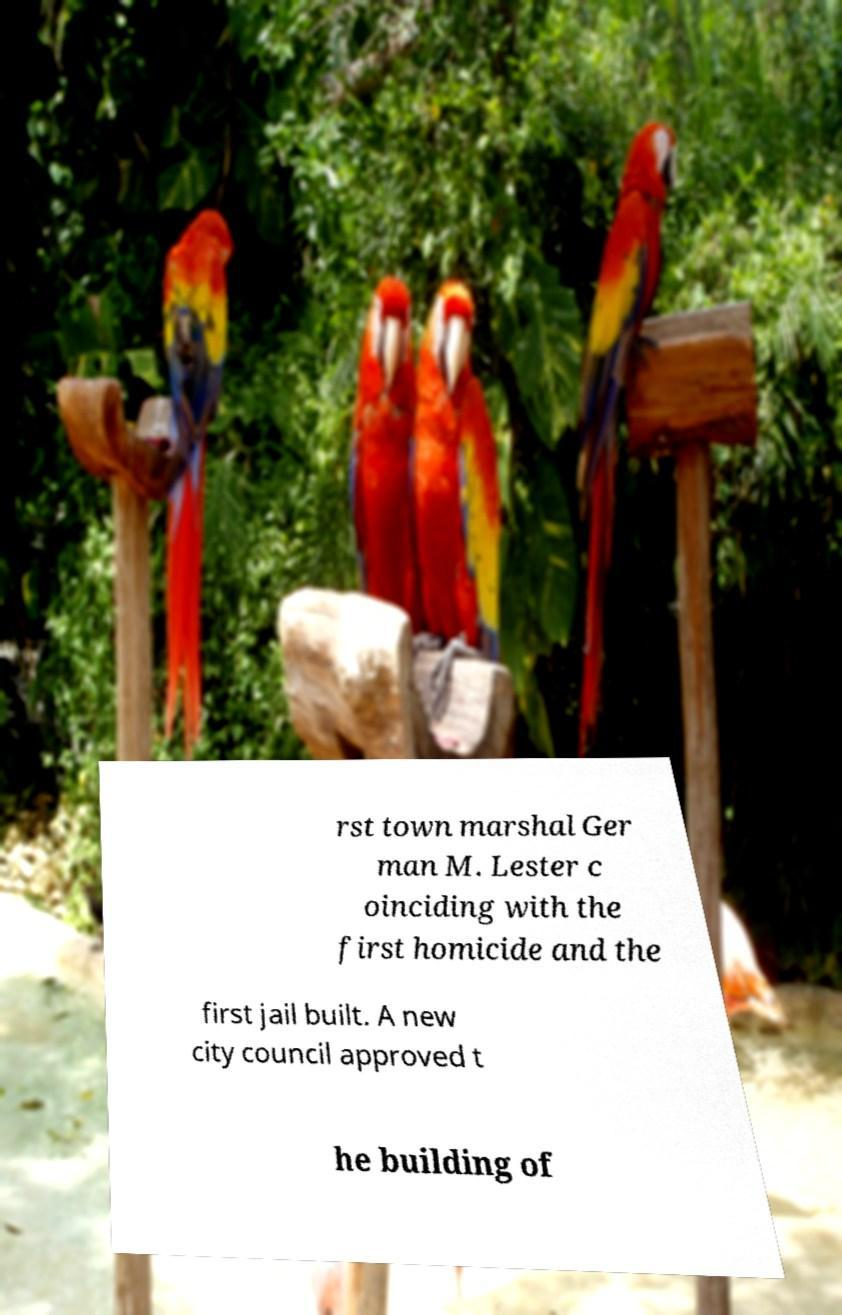Please read and relay the text visible in this image. What does it say? rst town marshal Ger man M. Lester c oinciding with the first homicide and the first jail built. A new city council approved t he building of 